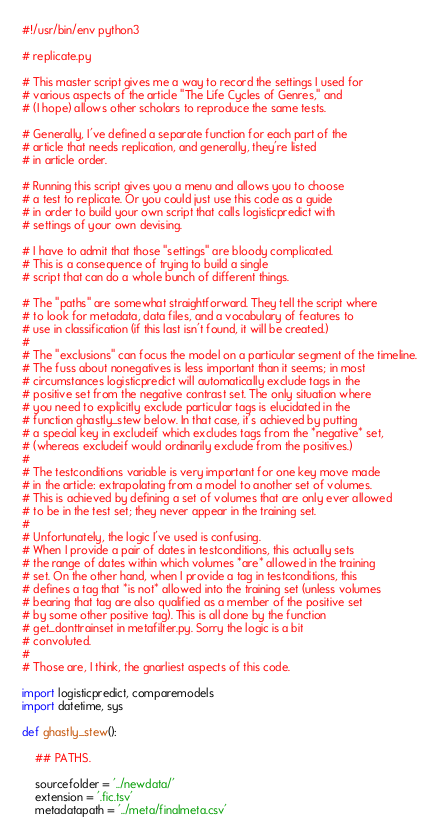Convert code to text. <code><loc_0><loc_0><loc_500><loc_500><_Python_>#!/usr/bin/env python3

# replicate.py

# This master script gives me a way to record the settings I used for
# various aspects of the article "The Life Cycles of Genres," and
# (I hope) allows other scholars to reproduce the same tests.

# Generally, I've defined a separate function for each part of the
# article that needs replication, and generally, they're listed
# in article order.

# Running this script gives you a menu and allows you to choose
# a test to replicate. Or you could just use this code as a guide
# in order to build your own script that calls logisticpredict with
# settings of your own devising.

# I have to admit that those "settings" are bloody complicated.
# This is a consequence of trying to build a single
# script that can do a whole bunch of different things.

# The "paths" are somewhat straightforward. They tell the script where
# to look for metadata, data files, and a vocabulary of features to
# use in classification (if this last isn't found, it will be created.)
#
# The "exclusions" can focus the model on a particular segment of the timeline.
# The fuss about nonegatives is less important than it seems; in most
# circumstances logisticpredict will automatically exclude tags in the
# positive set from the negative contrast set. The only situation where
# you need to explicitly exclude particular tags is elucidated in the
# function ghastly_stew below. In that case, it's achieved by putting
# a special key in excludeif which excludes tags from the *negative* set,
# (whereas excludeif would ordinarily exclude from the positives.)
#
# The testconditions variable is very important for one key move made
# in the article: extrapolating from a model to another set of volumes.
# This is achieved by defining a set of volumes that are only ever allowed
# to be in the test set; they never appear in the training set.
#
# Unfortunately, the logic I've used is confusing.
# When I provide a pair of dates in testconditions, this actually sets
# the range of dates within which volumes *are* allowed in the training
# set. On the other hand, when I provide a tag in testconditions, this
# defines a tag that *is not* allowed into the training set (unless volumes
# bearing that tag are also qualified as a member of the positive set
# by some other positive tag). This is all done by the function
# get_donttrainset in metafilter.py. Sorry the logic is a bit
# convoluted.
#
# Those are, I think, the gnarliest aspects of this code.

import logisticpredict, comparemodels
import datetime, sys

def ghastly_stew():

    ## PATHS.

    sourcefolder = '../newdata/'
    extension = '.fic.tsv'
    metadatapath = '../meta/finalmeta.csv'</code> 